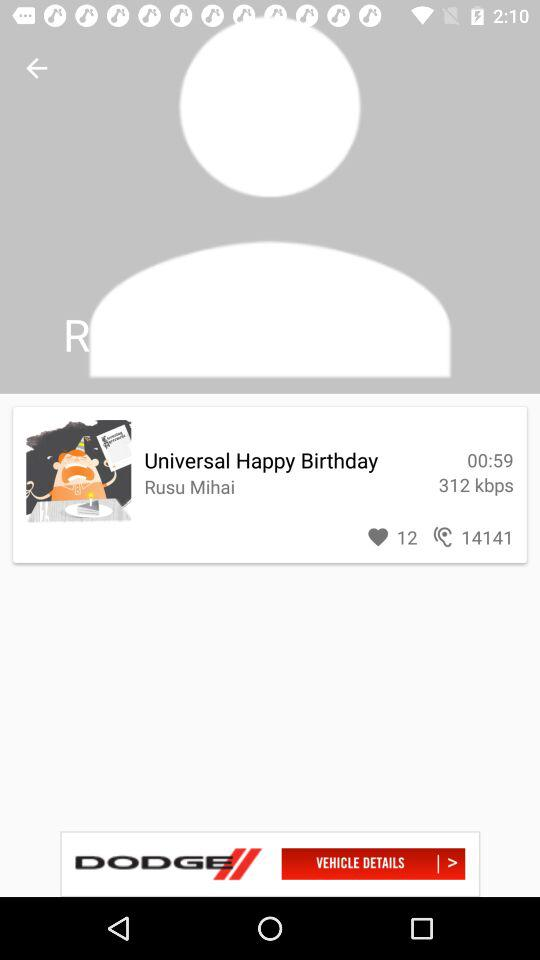What is the name of the application in the advertisement? The name of the application is "DODGE". 